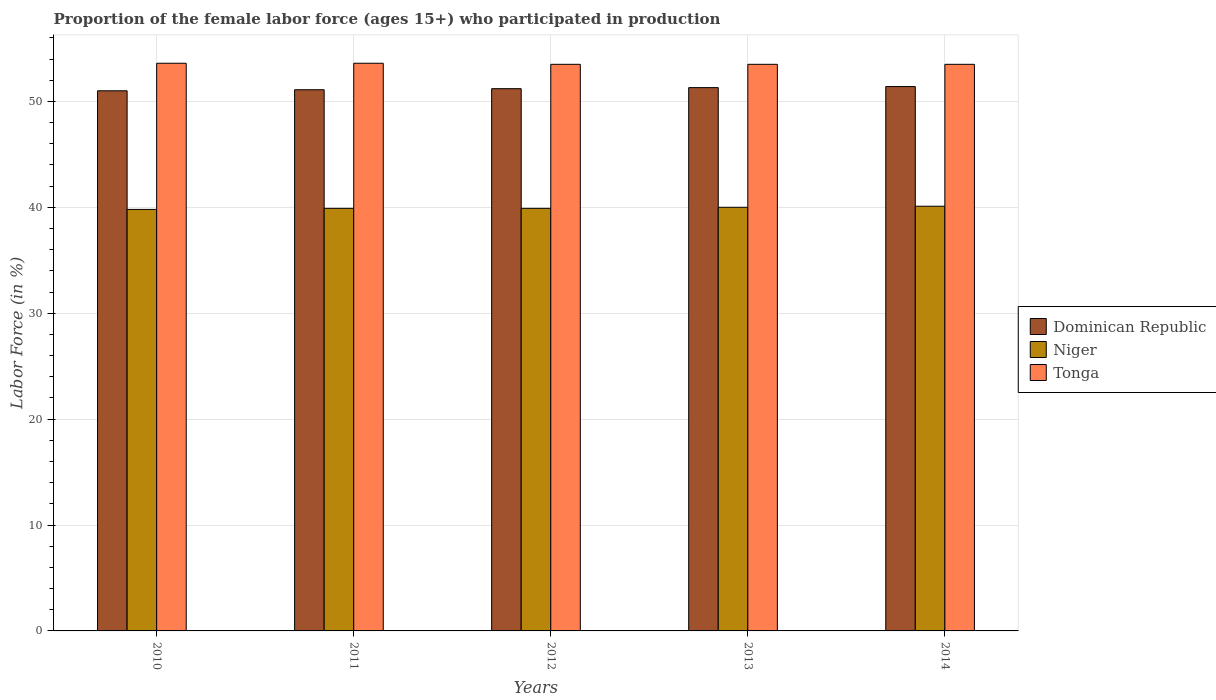How many groups of bars are there?
Offer a very short reply. 5. How many bars are there on the 3rd tick from the right?
Provide a short and direct response. 3. What is the label of the 2nd group of bars from the left?
Your response must be concise. 2011. In how many cases, is the number of bars for a given year not equal to the number of legend labels?
Offer a terse response. 0. What is the proportion of the female labor force who participated in production in Tonga in 2010?
Provide a short and direct response. 53.6. Across all years, what is the maximum proportion of the female labor force who participated in production in Dominican Republic?
Keep it short and to the point. 51.4. Across all years, what is the minimum proportion of the female labor force who participated in production in Niger?
Offer a terse response. 39.8. In which year was the proportion of the female labor force who participated in production in Tonga maximum?
Make the answer very short. 2010. What is the total proportion of the female labor force who participated in production in Niger in the graph?
Your response must be concise. 199.7. What is the difference between the proportion of the female labor force who participated in production in Niger in 2011 and that in 2013?
Your answer should be compact. -0.1. What is the difference between the proportion of the female labor force who participated in production in Dominican Republic in 2011 and the proportion of the female labor force who participated in production in Niger in 2013?
Make the answer very short. 11.1. What is the average proportion of the female labor force who participated in production in Tonga per year?
Ensure brevity in your answer.  53.54. In the year 2011, what is the difference between the proportion of the female labor force who participated in production in Tonga and proportion of the female labor force who participated in production in Dominican Republic?
Keep it short and to the point. 2.5. What is the ratio of the proportion of the female labor force who participated in production in Tonga in 2012 to that in 2014?
Your answer should be compact. 1. What is the difference between the highest and the second highest proportion of the female labor force who participated in production in Niger?
Offer a terse response. 0.1. What is the difference between the highest and the lowest proportion of the female labor force who participated in production in Tonga?
Your answer should be compact. 0.1. In how many years, is the proportion of the female labor force who participated in production in Tonga greater than the average proportion of the female labor force who participated in production in Tonga taken over all years?
Keep it short and to the point. 2. Is the sum of the proportion of the female labor force who participated in production in Niger in 2010 and 2012 greater than the maximum proportion of the female labor force who participated in production in Dominican Republic across all years?
Your response must be concise. Yes. What does the 2nd bar from the left in 2010 represents?
Your response must be concise. Niger. What does the 3rd bar from the right in 2013 represents?
Your answer should be compact. Dominican Republic. How many bars are there?
Your answer should be compact. 15. How many years are there in the graph?
Your response must be concise. 5. What is the difference between two consecutive major ticks on the Y-axis?
Provide a short and direct response. 10. Are the values on the major ticks of Y-axis written in scientific E-notation?
Your answer should be very brief. No. Does the graph contain grids?
Ensure brevity in your answer.  Yes. What is the title of the graph?
Offer a terse response. Proportion of the female labor force (ages 15+) who participated in production. What is the label or title of the X-axis?
Make the answer very short. Years. What is the Labor Force (in %) in Dominican Republic in 2010?
Your response must be concise. 51. What is the Labor Force (in %) in Niger in 2010?
Give a very brief answer. 39.8. What is the Labor Force (in %) in Tonga in 2010?
Provide a succinct answer. 53.6. What is the Labor Force (in %) of Dominican Republic in 2011?
Keep it short and to the point. 51.1. What is the Labor Force (in %) in Niger in 2011?
Your answer should be very brief. 39.9. What is the Labor Force (in %) of Tonga in 2011?
Your response must be concise. 53.6. What is the Labor Force (in %) of Dominican Republic in 2012?
Offer a very short reply. 51.2. What is the Labor Force (in %) in Niger in 2012?
Provide a succinct answer. 39.9. What is the Labor Force (in %) in Tonga in 2012?
Make the answer very short. 53.5. What is the Labor Force (in %) of Dominican Republic in 2013?
Offer a very short reply. 51.3. What is the Labor Force (in %) in Niger in 2013?
Ensure brevity in your answer.  40. What is the Labor Force (in %) of Tonga in 2013?
Provide a succinct answer. 53.5. What is the Labor Force (in %) in Dominican Republic in 2014?
Offer a terse response. 51.4. What is the Labor Force (in %) in Niger in 2014?
Your answer should be compact. 40.1. What is the Labor Force (in %) in Tonga in 2014?
Offer a terse response. 53.5. Across all years, what is the maximum Labor Force (in %) in Dominican Republic?
Your response must be concise. 51.4. Across all years, what is the maximum Labor Force (in %) of Niger?
Provide a succinct answer. 40.1. Across all years, what is the maximum Labor Force (in %) in Tonga?
Keep it short and to the point. 53.6. Across all years, what is the minimum Labor Force (in %) in Niger?
Make the answer very short. 39.8. Across all years, what is the minimum Labor Force (in %) in Tonga?
Your answer should be compact. 53.5. What is the total Labor Force (in %) of Dominican Republic in the graph?
Offer a very short reply. 256. What is the total Labor Force (in %) of Niger in the graph?
Your response must be concise. 199.7. What is the total Labor Force (in %) of Tonga in the graph?
Offer a very short reply. 267.7. What is the difference between the Labor Force (in %) in Dominican Republic in 2010 and that in 2012?
Give a very brief answer. -0.2. What is the difference between the Labor Force (in %) of Niger in 2010 and that in 2012?
Your response must be concise. -0.1. What is the difference between the Labor Force (in %) of Dominican Republic in 2010 and that in 2013?
Provide a succinct answer. -0.3. What is the difference between the Labor Force (in %) in Niger in 2010 and that in 2013?
Provide a succinct answer. -0.2. What is the difference between the Labor Force (in %) of Tonga in 2010 and that in 2013?
Your answer should be very brief. 0.1. What is the difference between the Labor Force (in %) in Tonga in 2010 and that in 2014?
Your answer should be compact. 0.1. What is the difference between the Labor Force (in %) of Tonga in 2011 and that in 2012?
Offer a very short reply. 0.1. What is the difference between the Labor Force (in %) in Dominican Republic in 2011 and that in 2013?
Make the answer very short. -0.2. What is the difference between the Labor Force (in %) in Niger in 2011 and that in 2014?
Offer a terse response. -0.2. What is the difference between the Labor Force (in %) of Tonga in 2011 and that in 2014?
Offer a very short reply. 0.1. What is the difference between the Labor Force (in %) of Tonga in 2012 and that in 2014?
Offer a very short reply. 0. What is the difference between the Labor Force (in %) of Niger in 2013 and that in 2014?
Give a very brief answer. -0.1. What is the difference between the Labor Force (in %) in Dominican Republic in 2010 and the Labor Force (in %) in Niger in 2011?
Make the answer very short. 11.1. What is the difference between the Labor Force (in %) of Niger in 2010 and the Labor Force (in %) of Tonga in 2012?
Make the answer very short. -13.7. What is the difference between the Labor Force (in %) in Dominican Republic in 2010 and the Labor Force (in %) in Tonga in 2013?
Offer a terse response. -2.5. What is the difference between the Labor Force (in %) in Niger in 2010 and the Labor Force (in %) in Tonga in 2013?
Provide a short and direct response. -13.7. What is the difference between the Labor Force (in %) in Dominican Republic in 2010 and the Labor Force (in %) in Niger in 2014?
Make the answer very short. 10.9. What is the difference between the Labor Force (in %) in Dominican Republic in 2010 and the Labor Force (in %) in Tonga in 2014?
Your answer should be very brief. -2.5. What is the difference between the Labor Force (in %) of Niger in 2010 and the Labor Force (in %) of Tonga in 2014?
Provide a short and direct response. -13.7. What is the difference between the Labor Force (in %) of Dominican Republic in 2011 and the Labor Force (in %) of Niger in 2012?
Give a very brief answer. 11.2. What is the difference between the Labor Force (in %) of Dominican Republic in 2011 and the Labor Force (in %) of Tonga in 2012?
Ensure brevity in your answer.  -2.4. What is the difference between the Labor Force (in %) in Niger in 2011 and the Labor Force (in %) in Tonga in 2012?
Provide a short and direct response. -13.6. What is the difference between the Labor Force (in %) of Dominican Republic in 2011 and the Labor Force (in %) of Tonga in 2014?
Keep it short and to the point. -2.4. What is the difference between the Labor Force (in %) in Dominican Republic in 2012 and the Labor Force (in %) in Tonga in 2013?
Your response must be concise. -2.3. What is the difference between the Labor Force (in %) in Dominican Republic in 2012 and the Labor Force (in %) in Niger in 2014?
Offer a very short reply. 11.1. What is the difference between the Labor Force (in %) in Niger in 2012 and the Labor Force (in %) in Tonga in 2014?
Keep it short and to the point. -13.6. What is the average Labor Force (in %) of Dominican Republic per year?
Give a very brief answer. 51.2. What is the average Labor Force (in %) of Niger per year?
Ensure brevity in your answer.  39.94. What is the average Labor Force (in %) of Tonga per year?
Offer a terse response. 53.54. In the year 2010, what is the difference between the Labor Force (in %) of Dominican Republic and Labor Force (in %) of Tonga?
Ensure brevity in your answer.  -2.6. In the year 2010, what is the difference between the Labor Force (in %) of Niger and Labor Force (in %) of Tonga?
Keep it short and to the point. -13.8. In the year 2011, what is the difference between the Labor Force (in %) in Dominican Republic and Labor Force (in %) in Niger?
Ensure brevity in your answer.  11.2. In the year 2011, what is the difference between the Labor Force (in %) in Niger and Labor Force (in %) in Tonga?
Your answer should be very brief. -13.7. In the year 2012, what is the difference between the Labor Force (in %) in Dominican Republic and Labor Force (in %) in Tonga?
Keep it short and to the point. -2.3. In the year 2013, what is the difference between the Labor Force (in %) in Dominican Republic and Labor Force (in %) in Tonga?
Ensure brevity in your answer.  -2.2. In the year 2013, what is the difference between the Labor Force (in %) in Niger and Labor Force (in %) in Tonga?
Ensure brevity in your answer.  -13.5. In the year 2014, what is the difference between the Labor Force (in %) of Dominican Republic and Labor Force (in %) of Tonga?
Make the answer very short. -2.1. In the year 2014, what is the difference between the Labor Force (in %) of Niger and Labor Force (in %) of Tonga?
Your response must be concise. -13.4. What is the ratio of the Labor Force (in %) in Niger in 2010 to that in 2011?
Make the answer very short. 1. What is the ratio of the Labor Force (in %) of Niger in 2010 to that in 2014?
Provide a succinct answer. 0.99. What is the ratio of the Labor Force (in %) in Tonga in 2010 to that in 2014?
Offer a very short reply. 1. What is the ratio of the Labor Force (in %) of Dominican Republic in 2011 to that in 2012?
Offer a terse response. 1. What is the ratio of the Labor Force (in %) in Dominican Republic in 2011 to that in 2013?
Offer a terse response. 1. What is the ratio of the Labor Force (in %) of Tonga in 2011 to that in 2013?
Provide a succinct answer. 1. What is the ratio of the Labor Force (in %) of Dominican Republic in 2011 to that in 2014?
Your answer should be compact. 0.99. What is the ratio of the Labor Force (in %) of Tonga in 2011 to that in 2014?
Your response must be concise. 1. What is the ratio of the Labor Force (in %) of Tonga in 2012 to that in 2013?
Ensure brevity in your answer.  1. What is the ratio of the Labor Force (in %) in Niger in 2012 to that in 2014?
Your answer should be very brief. 0.99. What is the ratio of the Labor Force (in %) of Niger in 2013 to that in 2014?
Give a very brief answer. 1. What is the difference between the highest and the lowest Labor Force (in %) of Dominican Republic?
Keep it short and to the point. 0.4. What is the difference between the highest and the lowest Labor Force (in %) of Niger?
Give a very brief answer. 0.3. What is the difference between the highest and the lowest Labor Force (in %) of Tonga?
Your response must be concise. 0.1. 